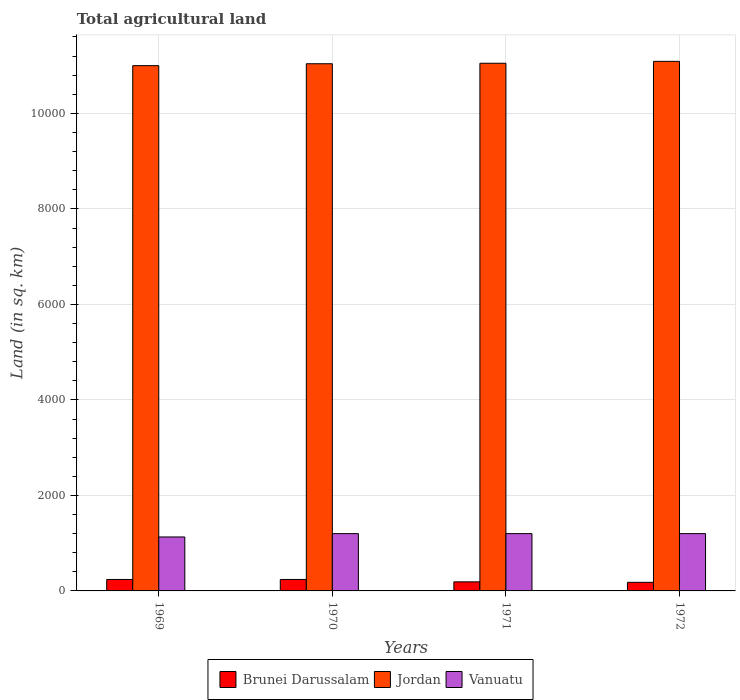How many groups of bars are there?
Keep it short and to the point. 4. Are the number of bars on each tick of the X-axis equal?
Make the answer very short. Yes. In how many cases, is the number of bars for a given year not equal to the number of legend labels?
Provide a succinct answer. 0. What is the total agricultural land in Brunei Darussalam in 1972?
Give a very brief answer. 180. Across all years, what is the maximum total agricultural land in Vanuatu?
Offer a terse response. 1200. Across all years, what is the minimum total agricultural land in Vanuatu?
Offer a terse response. 1130. In which year was the total agricultural land in Brunei Darussalam maximum?
Make the answer very short. 1969. In which year was the total agricultural land in Vanuatu minimum?
Ensure brevity in your answer.  1969. What is the total total agricultural land in Vanuatu in the graph?
Make the answer very short. 4730. What is the difference between the total agricultural land in Vanuatu in 1970 and that in 1972?
Keep it short and to the point. 0. What is the difference between the total agricultural land in Jordan in 1969 and the total agricultural land in Brunei Darussalam in 1971?
Your answer should be very brief. 1.08e+04. What is the average total agricultural land in Jordan per year?
Give a very brief answer. 1.10e+04. In the year 1969, what is the difference between the total agricultural land in Brunei Darussalam and total agricultural land in Vanuatu?
Your response must be concise. -890. What is the ratio of the total agricultural land in Brunei Darussalam in 1969 to that in 1971?
Provide a succinct answer. 1.26. Is the total agricultural land in Vanuatu in 1970 less than that in 1971?
Your answer should be very brief. No. Is the difference between the total agricultural land in Brunei Darussalam in 1969 and 1970 greater than the difference between the total agricultural land in Vanuatu in 1969 and 1970?
Your answer should be very brief. Yes. What is the difference between the highest and the lowest total agricultural land in Jordan?
Ensure brevity in your answer.  90. Is the sum of the total agricultural land in Brunei Darussalam in 1969 and 1971 greater than the maximum total agricultural land in Jordan across all years?
Ensure brevity in your answer.  No. What does the 3rd bar from the left in 1972 represents?
Keep it short and to the point. Vanuatu. What does the 2nd bar from the right in 1972 represents?
Provide a short and direct response. Jordan. Is it the case that in every year, the sum of the total agricultural land in Vanuatu and total agricultural land in Brunei Darussalam is greater than the total agricultural land in Jordan?
Provide a short and direct response. No. What is the difference between two consecutive major ticks on the Y-axis?
Make the answer very short. 2000. Are the values on the major ticks of Y-axis written in scientific E-notation?
Offer a terse response. No. Where does the legend appear in the graph?
Keep it short and to the point. Bottom center. How are the legend labels stacked?
Offer a very short reply. Horizontal. What is the title of the graph?
Give a very brief answer. Total agricultural land. Does "Turkmenistan" appear as one of the legend labels in the graph?
Your answer should be very brief. No. What is the label or title of the Y-axis?
Keep it short and to the point. Land (in sq. km). What is the Land (in sq. km) in Brunei Darussalam in 1969?
Offer a terse response. 240. What is the Land (in sq. km) of Jordan in 1969?
Make the answer very short. 1.10e+04. What is the Land (in sq. km) of Vanuatu in 1969?
Your answer should be compact. 1130. What is the Land (in sq. km) in Brunei Darussalam in 1970?
Make the answer very short. 240. What is the Land (in sq. km) in Jordan in 1970?
Ensure brevity in your answer.  1.10e+04. What is the Land (in sq. km) in Vanuatu in 1970?
Make the answer very short. 1200. What is the Land (in sq. km) in Brunei Darussalam in 1971?
Your response must be concise. 190. What is the Land (in sq. km) of Jordan in 1971?
Ensure brevity in your answer.  1.10e+04. What is the Land (in sq. km) of Vanuatu in 1971?
Give a very brief answer. 1200. What is the Land (in sq. km) in Brunei Darussalam in 1972?
Your answer should be very brief. 180. What is the Land (in sq. km) in Jordan in 1972?
Make the answer very short. 1.11e+04. What is the Land (in sq. km) of Vanuatu in 1972?
Make the answer very short. 1200. Across all years, what is the maximum Land (in sq. km) in Brunei Darussalam?
Offer a terse response. 240. Across all years, what is the maximum Land (in sq. km) in Jordan?
Offer a very short reply. 1.11e+04. Across all years, what is the maximum Land (in sq. km) in Vanuatu?
Provide a succinct answer. 1200. Across all years, what is the minimum Land (in sq. km) of Brunei Darussalam?
Give a very brief answer. 180. Across all years, what is the minimum Land (in sq. km) in Jordan?
Provide a short and direct response. 1.10e+04. Across all years, what is the minimum Land (in sq. km) in Vanuatu?
Keep it short and to the point. 1130. What is the total Land (in sq. km) in Brunei Darussalam in the graph?
Your answer should be compact. 850. What is the total Land (in sq. km) in Jordan in the graph?
Make the answer very short. 4.42e+04. What is the total Land (in sq. km) of Vanuatu in the graph?
Give a very brief answer. 4730. What is the difference between the Land (in sq. km) of Vanuatu in 1969 and that in 1970?
Make the answer very short. -70. What is the difference between the Land (in sq. km) in Jordan in 1969 and that in 1971?
Your answer should be very brief. -50. What is the difference between the Land (in sq. km) of Vanuatu in 1969 and that in 1971?
Offer a very short reply. -70. What is the difference between the Land (in sq. km) in Brunei Darussalam in 1969 and that in 1972?
Give a very brief answer. 60. What is the difference between the Land (in sq. km) of Jordan in 1969 and that in 1972?
Your answer should be compact. -90. What is the difference between the Land (in sq. km) of Vanuatu in 1969 and that in 1972?
Offer a terse response. -70. What is the difference between the Land (in sq. km) of Jordan in 1970 and that in 1971?
Offer a very short reply. -10. What is the difference between the Land (in sq. km) of Brunei Darussalam in 1970 and that in 1972?
Offer a terse response. 60. What is the difference between the Land (in sq. km) of Jordan in 1970 and that in 1972?
Offer a very short reply. -50. What is the difference between the Land (in sq. km) in Brunei Darussalam in 1969 and the Land (in sq. km) in Jordan in 1970?
Make the answer very short. -1.08e+04. What is the difference between the Land (in sq. km) of Brunei Darussalam in 1969 and the Land (in sq. km) of Vanuatu in 1970?
Your answer should be compact. -960. What is the difference between the Land (in sq. km) of Jordan in 1969 and the Land (in sq. km) of Vanuatu in 1970?
Your answer should be compact. 9800. What is the difference between the Land (in sq. km) in Brunei Darussalam in 1969 and the Land (in sq. km) in Jordan in 1971?
Keep it short and to the point. -1.08e+04. What is the difference between the Land (in sq. km) of Brunei Darussalam in 1969 and the Land (in sq. km) of Vanuatu in 1971?
Provide a succinct answer. -960. What is the difference between the Land (in sq. km) of Jordan in 1969 and the Land (in sq. km) of Vanuatu in 1971?
Offer a very short reply. 9800. What is the difference between the Land (in sq. km) of Brunei Darussalam in 1969 and the Land (in sq. km) of Jordan in 1972?
Your answer should be very brief. -1.08e+04. What is the difference between the Land (in sq. km) of Brunei Darussalam in 1969 and the Land (in sq. km) of Vanuatu in 1972?
Ensure brevity in your answer.  -960. What is the difference between the Land (in sq. km) of Jordan in 1969 and the Land (in sq. km) of Vanuatu in 1972?
Offer a terse response. 9800. What is the difference between the Land (in sq. km) in Brunei Darussalam in 1970 and the Land (in sq. km) in Jordan in 1971?
Your answer should be compact. -1.08e+04. What is the difference between the Land (in sq. km) in Brunei Darussalam in 1970 and the Land (in sq. km) in Vanuatu in 1971?
Offer a terse response. -960. What is the difference between the Land (in sq. km) in Jordan in 1970 and the Land (in sq. km) in Vanuatu in 1971?
Give a very brief answer. 9840. What is the difference between the Land (in sq. km) of Brunei Darussalam in 1970 and the Land (in sq. km) of Jordan in 1972?
Keep it short and to the point. -1.08e+04. What is the difference between the Land (in sq. km) of Brunei Darussalam in 1970 and the Land (in sq. km) of Vanuatu in 1972?
Offer a terse response. -960. What is the difference between the Land (in sq. km) in Jordan in 1970 and the Land (in sq. km) in Vanuatu in 1972?
Keep it short and to the point. 9840. What is the difference between the Land (in sq. km) in Brunei Darussalam in 1971 and the Land (in sq. km) in Jordan in 1972?
Provide a short and direct response. -1.09e+04. What is the difference between the Land (in sq. km) of Brunei Darussalam in 1971 and the Land (in sq. km) of Vanuatu in 1972?
Give a very brief answer. -1010. What is the difference between the Land (in sq. km) in Jordan in 1971 and the Land (in sq. km) in Vanuatu in 1972?
Your answer should be compact. 9850. What is the average Land (in sq. km) of Brunei Darussalam per year?
Provide a short and direct response. 212.5. What is the average Land (in sq. km) of Jordan per year?
Offer a very short reply. 1.10e+04. What is the average Land (in sq. km) in Vanuatu per year?
Give a very brief answer. 1182.5. In the year 1969, what is the difference between the Land (in sq. km) of Brunei Darussalam and Land (in sq. km) of Jordan?
Give a very brief answer. -1.08e+04. In the year 1969, what is the difference between the Land (in sq. km) in Brunei Darussalam and Land (in sq. km) in Vanuatu?
Provide a short and direct response. -890. In the year 1969, what is the difference between the Land (in sq. km) in Jordan and Land (in sq. km) in Vanuatu?
Keep it short and to the point. 9870. In the year 1970, what is the difference between the Land (in sq. km) of Brunei Darussalam and Land (in sq. km) of Jordan?
Provide a succinct answer. -1.08e+04. In the year 1970, what is the difference between the Land (in sq. km) of Brunei Darussalam and Land (in sq. km) of Vanuatu?
Provide a short and direct response. -960. In the year 1970, what is the difference between the Land (in sq. km) of Jordan and Land (in sq. km) of Vanuatu?
Keep it short and to the point. 9840. In the year 1971, what is the difference between the Land (in sq. km) of Brunei Darussalam and Land (in sq. km) of Jordan?
Keep it short and to the point. -1.09e+04. In the year 1971, what is the difference between the Land (in sq. km) in Brunei Darussalam and Land (in sq. km) in Vanuatu?
Keep it short and to the point. -1010. In the year 1971, what is the difference between the Land (in sq. km) of Jordan and Land (in sq. km) of Vanuatu?
Your response must be concise. 9850. In the year 1972, what is the difference between the Land (in sq. km) of Brunei Darussalam and Land (in sq. km) of Jordan?
Provide a succinct answer. -1.09e+04. In the year 1972, what is the difference between the Land (in sq. km) in Brunei Darussalam and Land (in sq. km) in Vanuatu?
Offer a very short reply. -1020. In the year 1972, what is the difference between the Land (in sq. km) in Jordan and Land (in sq. km) in Vanuatu?
Your answer should be compact. 9890. What is the ratio of the Land (in sq. km) in Vanuatu in 1969 to that in 1970?
Your answer should be compact. 0.94. What is the ratio of the Land (in sq. km) in Brunei Darussalam in 1969 to that in 1971?
Offer a very short reply. 1.26. What is the ratio of the Land (in sq. km) of Vanuatu in 1969 to that in 1971?
Your answer should be very brief. 0.94. What is the ratio of the Land (in sq. km) in Brunei Darussalam in 1969 to that in 1972?
Make the answer very short. 1.33. What is the ratio of the Land (in sq. km) in Jordan in 1969 to that in 1972?
Provide a succinct answer. 0.99. What is the ratio of the Land (in sq. km) of Vanuatu in 1969 to that in 1972?
Ensure brevity in your answer.  0.94. What is the ratio of the Land (in sq. km) of Brunei Darussalam in 1970 to that in 1971?
Give a very brief answer. 1.26. What is the ratio of the Land (in sq. km) of Jordan in 1970 to that in 1971?
Your response must be concise. 1. What is the ratio of the Land (in sq. km) of Jordan in 1970 to that in 1972?
Provide a short and direct response. 1. What is the ratio of the Land (in sq. km) of Brunei Darussalam in 1971 to that in 1972?
Your answer should be compact. 1.06. What is the difference between the highest and the second highest Land (in sq. km) of Brunei Darussalam?
Give a very brief answer. 0. What is the difference between the highest and the lowest Land (in sq. km) of Vanuatu?
Your answer should be compact. 70. 